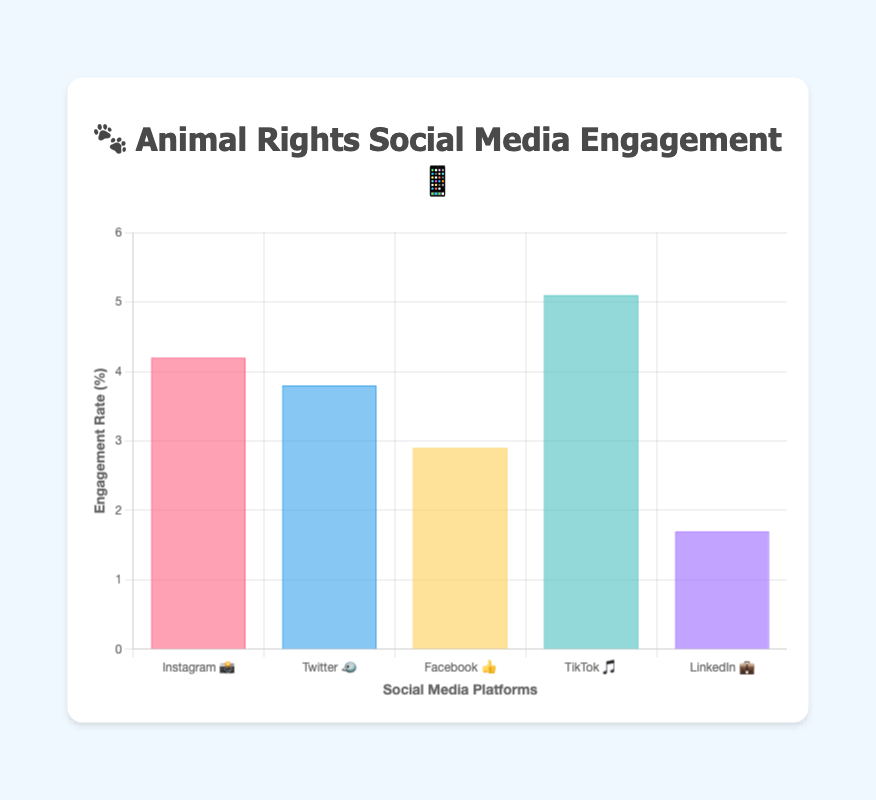Which platform has the highest engagement rate? The engagement rate for TikTok is the highest at 5.1%. This can be determined by reviewing all the bars and identifying that the bar representing TikTok is the tallest.
Answer: TikTok 🎵 Which platform has the lowest engagement rate? LinkedIn has the lowest engagement rate at 1.7%, which is identified by the shortest bar on the chart.
Answer: LinkedIn 💼 What is the difference in engagement rates between Instagram and Facebook? The engagement rate for Instagram is 4.2% and for Facebook is 2.9%. Subtracting these gives 4.2 - 2.9 = 1.3%.
Answer: 1.3% What is the total combined engagement rate for Instagram, Twitter, and Facebook? Adding the engagement rates for Instagram (4.2%), Twitter (3.8%), and Facebook (2.9%) gives 4.2 + 3.8 + 2.9 = 10.9%.
Answer: 10.9% How does Twitter's engagement rate compare to LinkedIn's? Twitter's engagement rate is 3.8%, while LinkedIn's is 1.7%. This indicates that Twitter's engagement rate is higher.
Answer: Twitter 🐦 What is the average engagement rate across all five platforms? The total sum of all engagement rates is 4.2 + 3.8 + 2.9 + 5.1 + 1.7 = 17.7. Dividing this by the number of platforms (5) gives 17.7 / 5 = 3.54%.
Answer: 3.54% Is there a platform with an engagement rate above 5%? By checking the values, TikTok is the only platform with an engagement rate of 5.1%, which is above 5%.
Answer: Yes, TikTok 🎵 Which platform has an engagement rate closest to 3%? The engagement rates around 3% are Facebook with 2.9% and Twitter with 3.8%. The closer one is Facebook with 2.9%.
Answer: Facebook 👍 